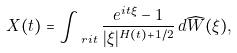Convert formula to latex. <formula><loc_0><loc_0><loc_500><loc_500>X ( t ) = \int _ { \ r i t } \frac { e ^ { i t \xi } - 1 } { | \xi | ^ { H ( t ) + 1 / 2 } } \, d \widehat { W } ( \xi ) ,</formula> 